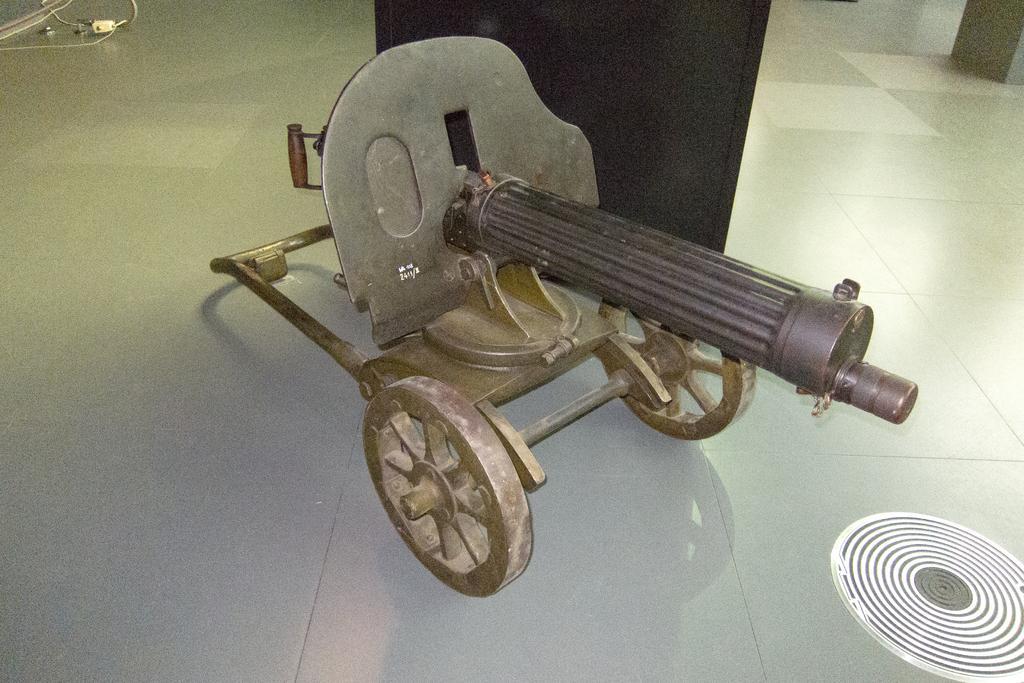How would you summarize this image in a sentence or two? In this picture we can see a maxim gun here, at the bottom there is floor. 